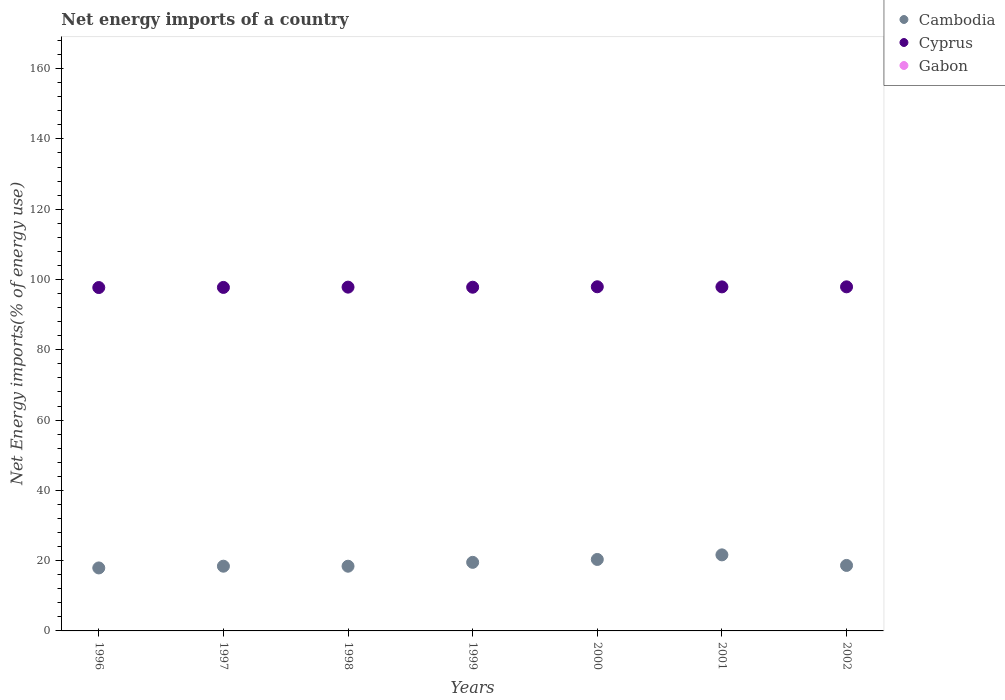How many different coloured dotlines are there?
Offer a terse response. 2. What is the net energy imports in Cambodia in 2002?
Your answer should be compact. 18.64. Across all years, what is the maximum net energy imports in Cambodia?
Your answer should be compact. 21.64. Across all years, what is the minimum net energy imports in Cyprus?
Offer a terse response. 97.71. In which year was the net energy imports in Cyprus maximum?
Ensure brevity in your answer.  2000. What is the total net energy imports in Cyprus in the graph?
Offer a very short reply. 684.82. What is the difference between the net energy imports in Cambodia in 1996 and that in 2001?
Offer a very short reply. -3.72. What is the difference between the net energy imports in Cyprus in 1998 and the net energy imports in Gabon in 2001?
Offer a very short reply. 97.83. In the year 2001, what is the difference between the net energy imports in Cyprus and net energy imports in Cambodia?
Your answer should be very brief. 76.26. In how many years, is the net energy imports in Cambodia greater than 36 %?
Your answer should be compact. 0. What is the ratio of the net energy imports in Cyprus in 1996 to that in 2001?
Ensure brevity in your answer.  1. Is the net energy imports in Cambodia in 2000 less than that in 2002?
Your answer should be very brief. No. Is the difference between the net energy imports in Cyprus in 1998 and 2002 greater than the difference between the net energy imports in Cambodia in 1998 and 2002?
Your response must be concise. Yes. What is the difference between the highest and the second highest net energy imports in Cyprus?
Your response must be concise. 0.02. What is the difference between the highest and the lowest net energy imports in Cambodia?
Provide a short and direct response. 3.72. Is the net energy imports in Cambodia strictly greater than the net energy imports in Gabon over the years?
Provide a short and direct response. Yes. How many dotlines are there?
Offer a very short reply. 2. Does the graph contain any zero values?
Offer a terse response. Yes. Does the graph contain grids?
Offer a terse response. No. Where does the legend appear in the graph?
Your answer should be compact. Top right. What is the title of the graph?
Give a very brief answer. Net energy imports of a country. What is the label or title of the Y-axis?
Your answer should be very brief. Net Energy imports(% of energy use). What is the Net Energy imports(% of energy use) of Cambodia in 1996?
Offer a very short reply. 17.92. What is the Net Energy imports(% of energy use) in Cyprus in 1996?
Your answer should be compact. 97.71. What is the Net Energy imports(% of energy use) in Cambodia in 1997?
Your answer should be very brief. 18.42. What is the Net Energy imports(% of energy use) of Cyprus in 1997?
Keep it short and to the point. 97.75. What is the Net Energy imports(% of energy use) in Gabon in 1997?
Make the answer very short. 0. What is the Net Energy imports(% of energy use) of Cambodia in 1998?
Provide a short and direct response. 18.41. What is the Net Energy imports(% of energy use) of Cyprus in 1998?
Give a very brief answer. 97.83. What is the Net Energy imports(% of energy use) of Gabon in 1998?
Give a very brief answer. 0. What is the Net Energy imports(% of energy use) of Cambodia in 1999?
Offer a terse response. 19.51. What is the Net Energy imports(% of energy use) in Cyprus in 1999?
Offer a very short reply. 97.8. What is the Net Energy imports(% of energy use) in Gabon in 1999?
Provide a succinct answer. 0. What is the Net Energy imports(% of energy use) of Cambodia in 2000?
Provide a succinct answer. 20.34. What is the Net Energy imports(% of energy use) in Cyprus in 2000?
Make the answer very short. 97.93. What is the Net Energy imports(% of energy use) in Cambodia in 2001?
Provide a succinct answer. 21.64. What is the Net Energy imports(% of energy use) in Cyprus in 2001?
Provide a short and direct response. 97.9. What is the Net Energy imports(% of energy use) of Cambodia in 2002?
Your answer should be very brief. 18.64. What is the Net Energy imports(% of energy use) of Cyprus in 2002?
Your response must be concise. 97.91. What is the Net Energy imports(% of energy use) of Gabon in 2002?
Provide a succinct answer. 0. Across all years, what is the maximum Net Energy imports(% of energy use) in Cambodia?
Offer a terse response. 21.64. Across all years, what is the maximum Net Energy imports(% of energy use) in Cyprus?
Offer a terse response. 97.93. Across all years, what is the minimum Net Energy imports(% of energy use) of Cambodia?
Offer a very short reply. 17.92. Across all years, what is the minimum Net Energy imports(% of energy use) in Cyprus?
Your response must be concise. 97.71. What is the total Net Energy imports(% of energy use) of Cambodia in the graph?
Your response must be concise. 134.88. What is the total Net Energy imports(% of energy use) in Cyprus in the graph?
Ensure brevity in your answer.  684.82. What is the total Net Energy imports(% of energy use) of Gabon in the graph?
Your answer should be very brief. 0. What is the difference between the Net Energy imports(% of energy use) in Cambodia in 1996 and that in 1997?
Offer a very short reply. -0.49. What is the difference between the Net Energy imports(% of energy use) of Cyprus in 1996 and that in 1997?
Your answer should be compact. -0.04. What is the difference between the Net Energy imports(% of energy use) of Cambodia in 1996 and that in 1998?
Provide a short and direct response. -0.49. What is the difference between the Net Energy imports(% of energy use) of Cyprus in 1996 and that in 1998?
Make the answer very short. -0.12. What is the difference between the Net Energy imports(% of energy use) in Cambodia in 1996 and that in 1999?
Provide a succinct answer. -1.59. What is the difference between the Net Energy imports(% of energy use) in Cyprus in 1996 and that in 1999?
Your answer should be very brief. -0.09. What is the difference between the Net Energy imports(% of energy use) of Cambodia in 1996 and that in 2000?
Provide a succinct answer. -2.41. What is the difference between the Net Energy imports(% of energy use) in Cyprus in 1996 and that in 2000?
Offer a terse response. -0.22. What is the difference between the Net Energy imports(% of energy use) of Cambodia in 1996 and that in 2001?
Ensure brevity in your answer.  -3.72. What is the difference between the Net Energy imports(% of energy use) of Cyprus in 1996 and that in 2001?
Keep it short and to the point. -0.19. What is the difference between the Net Energy imports(% of energy use) in Cambodia in 1996 and that in 2002?
Give a very brief answer. -0.71. What is the difference between the Net Energy imports(% of energy use) of Cyprus in 1996 and that in 2002?
Keep it short and to the point. -0.2. What is the difference between the Net Energy imports(% of energy use) of Cambodia in 1997 and that in 1998?
Keep it short and to the point. 0. What is the difference between the Net Energy imports(% of energy use) of Cyprus in 1997 and that in 1998?
Provide a short and direct response. -0.08. What is the difference between the Net Energy imports(% of energy use) in Cambodia in 1997 and that in 1999?
Offer a terse response. -1.1. What is the difference between the Net Energy imports(% of energy use) in Cyprus in 1997 and that in 1999?
Provide a succinct answer. -0.06. What is the difference between the Net Energy imports(% of energy use) in Cambodia in 1997 and that in 2000?
Ensure brevity in your answer.  -1.92. What is the difference between the Net Energy imports(% of energy use) of Cyprus in 1997 and that in 2000?
Make the answer very short. -0.18. What is the difference between the Net Energy imports(% of energy use) of Cambodia in 1997 and that in 2001?
Your answer should be compact. -3.22. What is the difference between the Net Energy imports(% of energy use) in Cyprus in 1997 and that in 2001?
Provide a succinct answer. -0.15. What is the difference between the Net Energy imports(% of energy use) in Cambodia in 1997 and that in 2002?
Your answer should be very brief. -0.22. What is the difference between the Net Energy imports(% of energy use) of Cyprus in 1997 and that in 2002?
Give a very brief answer. -0.17. What is the difference between the Net Energy imports(% of energy use) in Cyprus in 1998 and that in 1999?
Ensure brevity in your answer.  0.02. What is the difference between the Net Energy imports(% of energy use) in Cambodia in 1998 and that in 2000?
Ensure brevity in your answer.  -1.92. What is the difference between the Net Energy imports(% of energy use) in Cyprus in 1998 and that in 2000?
Offer a very short reply. -0.1. What is the difference between the Net Energy imports(% of energy use) in Cambodia in 1998 and that in 2001?
Your answer should be very brief. -3.23. What is the difference between the Net Energy imports(% of energy use) in Cyprus in 1998 and that in 2001?
Give a very brief answer. -0.07. What is the difference between the Net Energy imports(% of energy use) of Cambodia in 1998 and that in 2002?
Provide a succinct answer. -0.22. What is the difference between the Net Energy imports(% of energy use) of Cyprus in 1998 and that in 2002?
Your answer should be very brief. -0.09. What is the difference between the Net Energy imports(% of energy use) in Cambodia in 1999 and that in 2000?
Offer a very short reply. -0.82. What is the difference between the Net Energy imports(% of energy use) in Cyprus in 1999 and that in 2000?
Ensure brevity in your answer.  -0.13. What is the difference between the Net Energy imports(% of energy use) in Cambodia in 1999 and that in 2001?
Your answer should be very brief. -2.13. What is the difference between the Net Energy imports(% of energy use) of Cyprus in 1999 and that in 2001?
Offer a very short reply. -0.09. What is the difference between the Net Energy imports(% of energy use) of Cambodia in 1999 and that in 2002?
Offer a terse response. 0.88. What is the difference between the Net Energy imports(% of energy use) in Cyprus in 1999 and that in 2002?
Your response must be concise. -0.11. What is the difference between the Net Energy imports(% of energy use) in Cambodia in 2000 and that in 2001?
Provide a short and direct response. -1.31. What is the difference between the Net Energy imports(% of energy use) of Cyprus in 2000 and that in 2001?
Provide a succinct answer. 0.03. What is the difference between the Net Energy imports(% of energy use) of Cambodia in 2000 and that in 2002?
Offer a terse response. 1.7. What is the difference between the Net Energy imports(% of energy use) of Cyprus in 2000 and that in 2002?
Keep it short and to the point. 0.02. What is the difference between the Net Energy imports(% of energy use) of Cambodia in 2001 and that in 2002?
Offer a terse response. 3.01. What is the difference between the Net Energy imports(% of energy use) in Cyprus in 2001 and that in 2002?
Your answer should be compact. -0.02. What is the difference between the Net Energy imports(% of energy use) in Cambodia in 1996 and the Net Energy imports(% of energy use) in Cyprus in 1997?
Make the answer very short. -79.82. What is the difference between the Net Energy imports(% of energy use) of Cambodia in 1996 and the Net Energy imports(% of energy use) of Cyprus in 1998?
Your response must be concise. -79.9. What is the difference between the Net Energy imports(% of energy use) of Cambodia in 1996 and the Net Energy imports(% of energy use) of Cyprus in 1999?
Make the answer very short. -79.88. What is the difference between the Net Energy imports(% of energy use) in Cambodia in 1996 and the Net Energy imports(% of energy use) in Cyprus in 2000?
Provide a short and direct response. -80.01. What is the difference between the Net Energy imports(% of energy use) in Cambodia in 1996 and the Net Energy imports(% of energy use) in Cyprus in 2001?
Provide a short and direct response. -79.97. What is the difference between the Net Energy imports(% of energy use) in Cambodia in 1996 and the Net Energy imports(% of energy use) in Cyprus in 2002?
Make the answer very short. -79.99. What is the difference between the Net Energy imports(% of energy use) in Cambodia in 1997 and the Net Energy imports(% of energy use) in Cyprus in 1998?
Make the answer very short. -79.41. What is the difference between the Net Energy imports(% of energy use) in Cambodia in 1997 and the Net Energy imports(% of energy use) in Cyprus in 1999?
Keep it short and to the point. -79.39. What is the difference between the Net Energy imports(% of energy use) in Cambodia in 1997 and the Net Energy imports(% of energy use) in Cyprus in 2000?
Ensure brevity in your answer.  -79.51. What is the difference between the Net Energy imports(% of energy use) of Cambodia in 1997 and the Net Energy imports(% of energy use) of Cyprus in 2001?
Your response must be concise. -79.48. What is the difference between the Net Energy imports(% of energy use) of Cambodia in 1997 and the Net Energy imports(% of energy use) of Cyprus in 2002?
Your answer should be compact. -79.5. What is the difference between the Net Energy imports(% of energy use) in Cambodia in 1998 and the Net Energy imports(% of energy use) in Cyprus in 1999?
Make the answer very short. -79.39. What is the difference between the Net Energy imports(% of energy use) of Cambodia in 1998 and the Net Energy imports(% of energy use) of Cyprus in 2000?
Keep it short and to the point. -79.52. What is the difference between the Net Energy imports(% of energy use) in Cambodia in 1998 and the Net Energy imports(% of energy use) in Cyprus in 2001?
Offer a terse response. -79.48. What is the difference between the Net Energy imports(% of energy use) of Cambodia in 1998 and the Net Energy imports(% of energy use) of Cyprus in 2002?
Your answer should be very brief. -79.5. What is the difference between the Net Energy imports(% of energy use) of Cambodia in 1999 and the Net Energy imports(% of energy use) of Cyprus in 2000?
Ensure brevity in your answer.  -78.42. What is the difference between the Net Energy imports(% of energy use) in Cambodia in 1999 and the Net Energy imports(% of energy use) in Cyprus in 2001?
Give a very brief answer. -78.38. What is the difference between the Net Energy imports(% of energy use) of Cambodia in 1999 and the Net Energy imports(% of energy use) of Cyprus in 2002?
Your answer should be compact. -78.4. What is the difference between the Net Energy imports(% of energy use) in Cambodia in 2000 and the Net Energy imports(% of energy use) in Cyprus in 2001?
Ensure brevity in your answer.  -77.56. What is the difference between the Net Energy imports(% of energy use) in Cambodia in 2000 and the Net Energy imports(% of energy use) in Cyprus in 2002?
Ensure brevity in your answer.  -77.58. What is the difference between the Net Energy imports(% of energy use) in Cambodia in 2001 and the Net Energy imports(% of energy use) in Cyprus in 2002?
Provide a short and direct response. -76.27. What is the average Net Energy imports(% of energy use) of Cambodia per year?
Offer a terse response. 19.27. What is the average Net Energy imports(% of energy use) of Cyprus per year?
Provide a short and direct response. 97.83. What is the average Net Energy imports(% of energy use) in Gabon per year?
Offer a terse response. 0. In the year 1996, what is the difference between the Net Energy imports(% of energy use) of Cambodia and Net Energy imports(% of energy use) of Cyprus?
Your answer should be very brief. -79.79. In the year 1997, what is the difference between the Net Energy imports(% of energy use) in Cambodia and Net Energy imports(% of energy use) in Cyprus?
Keep it short and to the point. -79.33. In the year 1998, what is the difference between the Net Energy imports(% of energy use) of Cambodia and Net Energy imports(% of energy use) of Cyprus?
Your answer should be compact. -79.41. In the year 1999, what is the difference between the Net Energy imports(% of energy use) of Cambodia and Net Energy imports(% of energy use) of Cyprus?
Provide a succinct answer. -78.29. In the year 2000, what is the difference between the Net Energy imports(% of energy use) of Cambodia and Net Energy imports(% of energy use) of Cyprus?
Offer a terse response. -77.59. In the year 2001, what is the difference between the Net Energy imports(% of energy use) of Cambodia and Net Energy imports(% of energy use) of Cyprus?
Ensure brevity in your answer.  -76.25. In the year 2002, what is the difference between the Net Energy imports(% of energy use) in Cambodia and Net Energy imports(% of energy use) in Cyprus?
Make the answer very short. -79.28. What is the ratio of the Net Energy imports(% of energy use) in Cambodia in 1996 to that in 1997?
Your response must be concise. 0.97. What is the ratio of the Net Energy imports(% of energy use) in Cambodia in 1996 to that in 1998?
Your answer should be very brief. 0.97. What is the ratio of the Net Energy imports(% of energy use) in Cyprus in 1996 to that in 1998?
Give a very brief answer. 1. What is the ratio of the Net Energy imports(% of energy use) in Cambodia in 1996 to that in 1999?
Make the answer very short. 0.92. What is the ratio of the Net Energy imports(% of energy use) of Cambodia in 1996 to that in 2000?
Give a very brief answer. 0.88. What is the ratio of the Net Energy imports(% of energy use) of Cyprus in 1996 to that in 2000?
Your response must be concise. 1. What is the ratio of the Net Energy imports(% of energy use) of Cambodia in 1996 to that in 2001?
Offer a very short reply. 0.83. What is the ratio of the Net Energy imports(% of energy use) of Cyprus in 1996 to that in 2001?
Provide a short and direct response. 1. What is the ratio of the Net Energy imports(% of energy use) of Cambodia in 1996 to that in 2002?
Offer a very short reply. 0.96. What is the ratio of the Net Energy imports(% of energy use) in Cambodia in 1997 to that in 1998?
Make the answer very short. 1. What is the ratio of the Net Energy imports(% of energy use) of Cyprus in 1997 to that in 1998?
Ensure brevity in your answer.  1. What is the ratio of the Net Energy imports(% of energy use) of Cambodia in 1997 to that in 1999?
Ensure brevity in your answer.  0.94. What is the ratio of the Net Energy imports(% of energy use) of Cyprus in 1997 to that in 1999?
Provide a succinct answer. 1. What is the ratio of the Net Energy imports(% of energy use) in Cambodia in 1997 to that in 2000?
Offer a terse response. 0.91. What is the ratio of the Net Energy imports(% of energy use) of Cambodia in 1997 to that in 2001?
Your answer should be compact. 0.85. What is the ratio of the Net Energy imports(% of energy use) in Cyprus in 1997 to that in 2002?
Give a very brief answer. 1. What is the ratio of the Net Energy imports(% of energy use) in Cambodia in 1998 to that in 1999?
Offer a very short reply. 0.94. What is the ratio of the Net Energy imports(% of energy use) of Cambodia in 1998 to that in 2000?
Provide a short and direct response. 0.91. What is the ratio of the Net Energy imports(% of energy use) in Cyprus in 1998 to that in 2000?
Give a very brief answer. 1. What is the ratio of the Net Energy imports(% of energy use) of Cambodia in 1998 to that in 2001?
Offer a terse response. 0.85. What is the ratio of the Net Energy imports(% of energy use) in Cyprus in 1998 to that in 2001?
Make the answer very short. 1. What is the ratio of the Net Energy imports(% of energy use) of Cambodia in 1998 to that in 2002?
Offer a very short reply. 0.99. What is the ratio of the Net Energy imports(% of energy use) of Cambodia in 1999 to that in 2000?
Give a very brief answer. 0.96. What is the ratio of the Net Energy imports(% of energy use) in Cambodia in 1999 to that in 2001?
Offer a terse response. 0.9. What is the ratio of the Net Energy imports(% of energy use) in Cambodia in 1999 to that in 2002?
Keep it short and to the point. 1.05. What is the ratio of the Net Energy imports(% of energy use) of Cambodia in 2000 to that in 2001?
Ensure brevity in your answer.  0.94. What is the ratio of the Net Energy imports(% of energy use) in Cambodia in 2000 to that in 2002?
Give a very brief answer. 1.09. What is the ratio of the Net Energy imports(% of energy use) of Cyprus in 2000 to that in 2002?
Your answer should be compact. 1. What is the ratio of the Net Energy imports(% of energy use) in Cambodia in 2001 to that in 2002?
Your answer should be very brief. 1.16. What is the ratio of the Net Energy imports(% of energy use) in Cyprus in 2001 to that in 2002?
Make the answer very short. 1. What is the difference between the highest and the second highest Net Energy imports(% of energy use) of Cambodia?
Keep it short and to the point. 1.31. What is the difference between the highest and the second highest Net Energy imports(% of energy use) of Cyprus?
Make the answer very short. 0.02. What is the difference between the highest and the lowest Net Energy imports(% of energy use) of Cambodia?
Your answer should be compact. 3.72. What is the difference between the highest and the lowest Net Energy imports(% of energy use) of Cyprus?
Your answer should be compact. 0.22. 